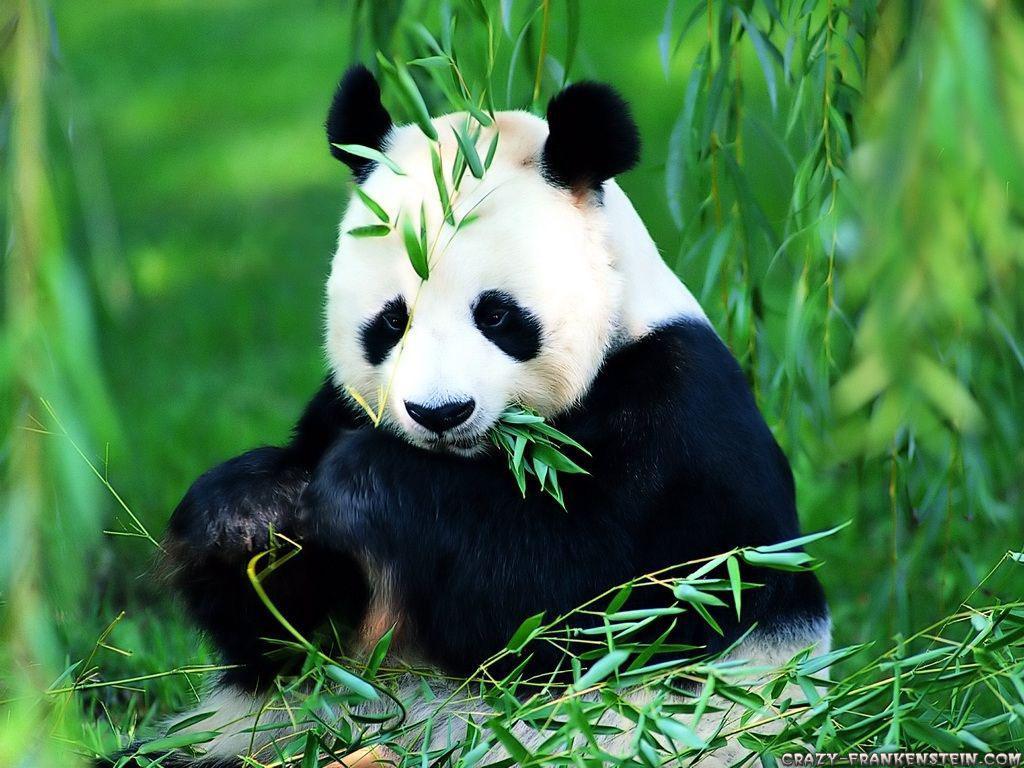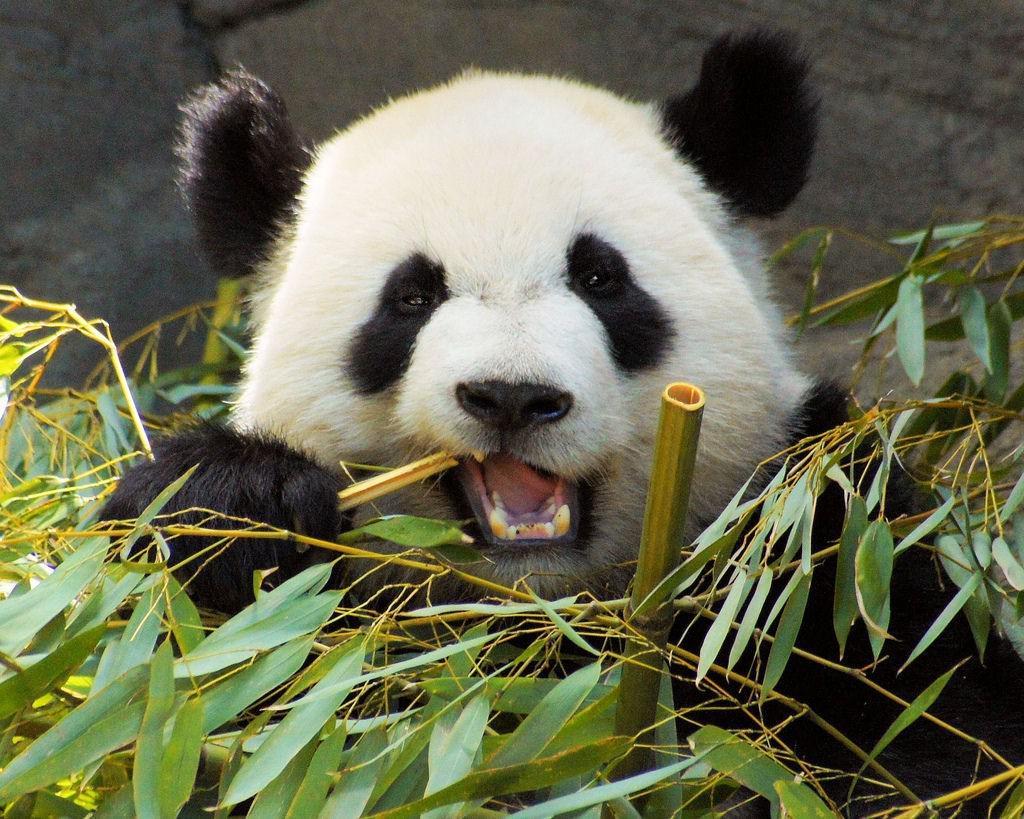The first image is the image on the left, the second image is the image on the right. Evaluate the accuracy of this statement regarding the images: "Each image shows one forward-facing panda munching something, but the panda on the left is munching green leaves, while the panda on the right is munching yellow stalks.". Is it true? Answer yes or no. Yes. 